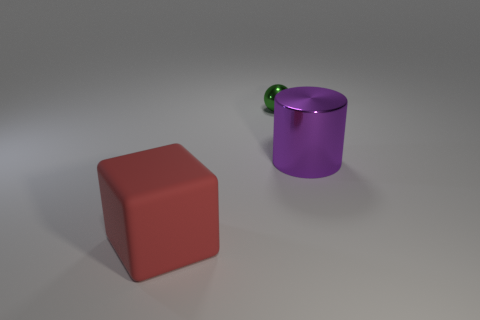Add 2 green shiny spheres. How many objects exist? 5 Subtract all spheres. How many objects are left? 2 Add 1 big matte blocks. How many big matte blocks are left? 2 Add 2 shiny spheres. How many shiny spheres exist? 3 Subtract 0 gray cylinders. How many objects are left? 3 Subtract all small purple objects. Subtract all big red matte cubes. How many objects are left? 2 